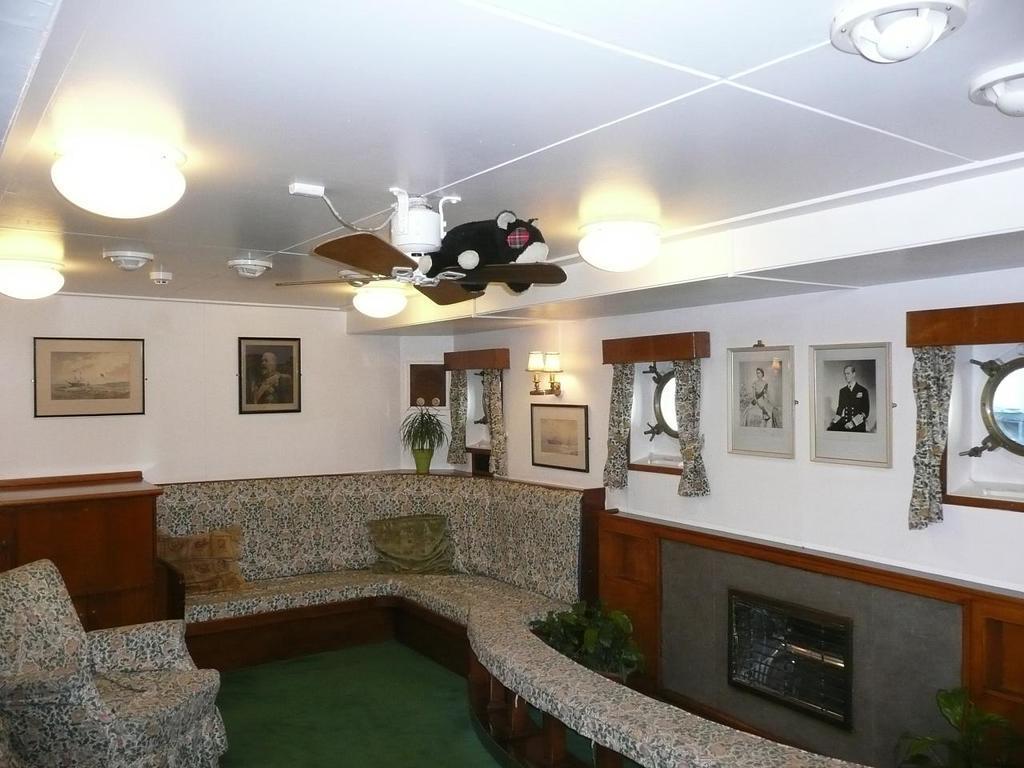How would you summarize this image in a sentence or two? In this image it looks like a sofa and there is a wooden object on the left corner. There are potted plants and frames on the wall, there are curtains, there are lights on the right corner. There is floor at the bottom. There is a sofa and there are pillows, potted plants in the foreground. And there are frames on the wall in the background. And there are lights on the roof at the top. 